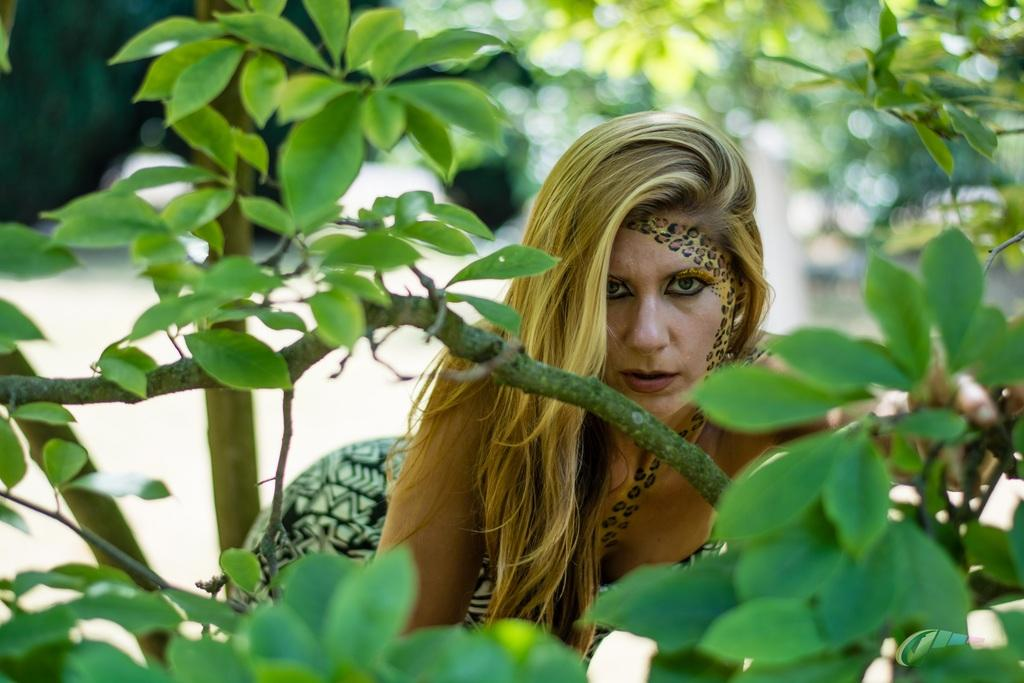What type of vegetation can be seen in the foreground of the image? There are branches in the foreground area of the image. What can be seen behind the branches in the image? There is a lady visible behind the branches. How does the lady move across the bridge in the image? There is no bridge present in the image, and the lady is not shown moving. 